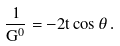<formula> <loc_0><loc_0><loc_500><loc_500>\frac { 1 } { G ^ { 0 } } = - 2 t \cos \theta \, .</formula> 